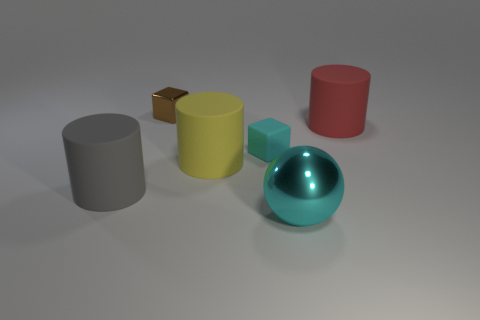Can you describe the lighting in this image? The lighting in the image seems to be diffused, illuminating the scene evenly from above, with soft shadows cast under the objects which suggest an indoor setting with a single light source, likely artificial like a ceiling lamp. 